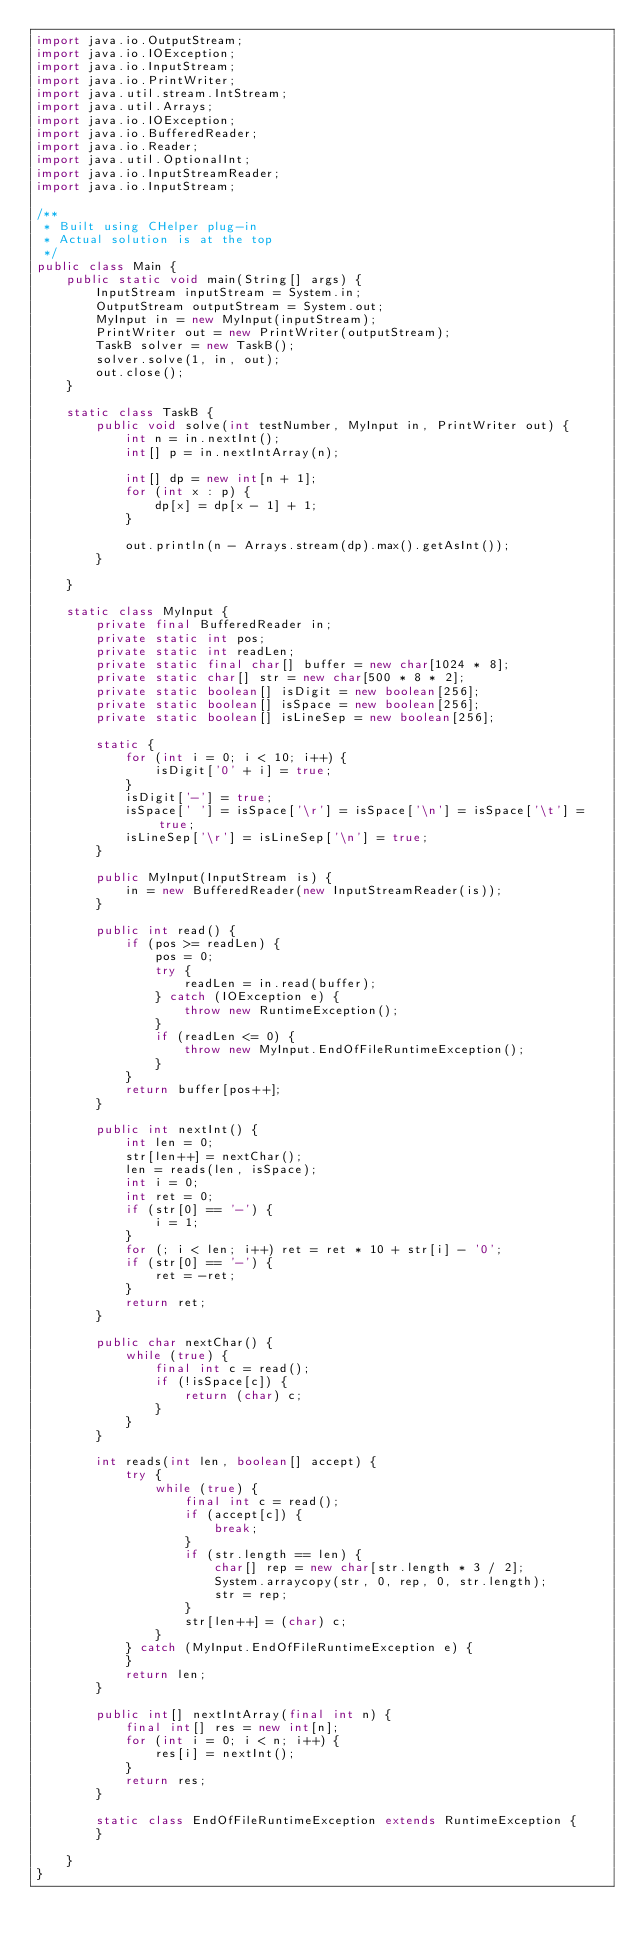Convert code to text. <code><loc_0><loc_0><loc_500><loc_500><_Java_>import java.io.OutputStream;
import java.io.IOException;
import java.io.InputStream;
import java.io.PrintWriter;
import java.util.stream.IntStream;
import java.util.Arrays;
import java.io.IOException;
import java.io.BufferedReader;
import java.io.Reader;
import java.util.OptionalInt;
import java.io.InputStreamReader;
import java.io.InputStream;

/**
 * Built using CHelper plug-in
 * Actual solution is at the top
 */
public class Main {
    public static void main(String[] args) {
        InputStream inputStream = System.in;
        OutputStream outputStream = System.out;
        MyInput in = new MyInput(inputStream);
        PrintWriter out = new PrintWriter(outputStream);
        TaskB solver = new TaskB();
        solver.solve(1, in, out);
        out.close();
    }

    static class TaskB {
        public void solve(int testNumber, MyInput in, PrintWriter out) {
            int n = in.nextInt();
            int[] p = in.nextIntArray(n);

            int[] dp = new int[n + 1];
            for (int x : p) {
                dp[x] = dp[x - 1] + 1;
            }

            out.println(n - Arrays.stream(dp).max().getAsInt());
        }

    }

    static class MyInput {
        private final BufferedReader in;
        private static int pos;
        private static int readLen;
        private static final char[] buffer = new char[1024 * 8];
        private static char[] str = new char[500 * 8 * 2];
        private static boolean[] isDigit = new boolean[256];
        private static boolean[] isSpace = new boolean[256];
        private static boolean[] isLineSep = new boolean[256];

        static {
            for (int i = 0; i < 10; i++) {
                isDigit['0' + i] = true;
            }
            isDigit['-'] = true;
            isSpace[' '] = isSpace['\r'] = isSpace['\n'] = isSpace['\t'] = true;
            isLineSep['\r'] = isLineSep['\n'] = true;
        }

        public MyInput(InputStream is) {
            in = new BufferedReader(new InputStreamReader(is));
        }

        public int read() {
            if (pos >= readLen) {
                pos = 0;
                try {
                    readLen = in.read(buffer);
                } catch (IOException e) {
                    throw new RuntimeException();
                }
                if (readLen <= 0) {
                    throw new MyInput.EndOfFileRuntimeException();
                }
            }
            return buffer[pos++];
        }

        public int nextInt() {
            int len = 0;
            str[len++] = nextChar();
            len = reads(len, isSpace);
            int i = 0;
            int ret = 0;
            if (str[0] == '-') {
                i = 1;
            }
            for (; i < len; i++) ret = ret * 10 + str[i] - '0';
            if (str[0] == '-') {
                ret = -ret;
            }
            return ret;
        }

        public char nextChar() {
            while (true) {
                final int c = read();
                if (!isSpace[c]) {
                    return (char) c;
                }
            }
        }

        int reads(int len, boolean[] accept) {
            try {
                while (true) {
                    final int c = read();
                    if (accept[c]) {
                        break;
                    }
                    if (str.length == len) {
                        char[] rep = new char[str.length * 3 / 2];
                        System.arraycopy(str, 0, rep, 0, str.length);
                        str = rep;
                    }
                    str[len++] = (char) c;
                }
            } catch (MyInput.EndOfFileRuntimeException e) {
            }
            return len;
        }

        public int[] nextIntArray(final int n) {
            final int[] res = new int[n];
            for (int i = 0; i < n; i++) {
                res[i] = nextInt();
            }
            return res;
        }

        static class EndOfFileRuntimeException extends RuntimeException {
        }

    }
}

</code> 